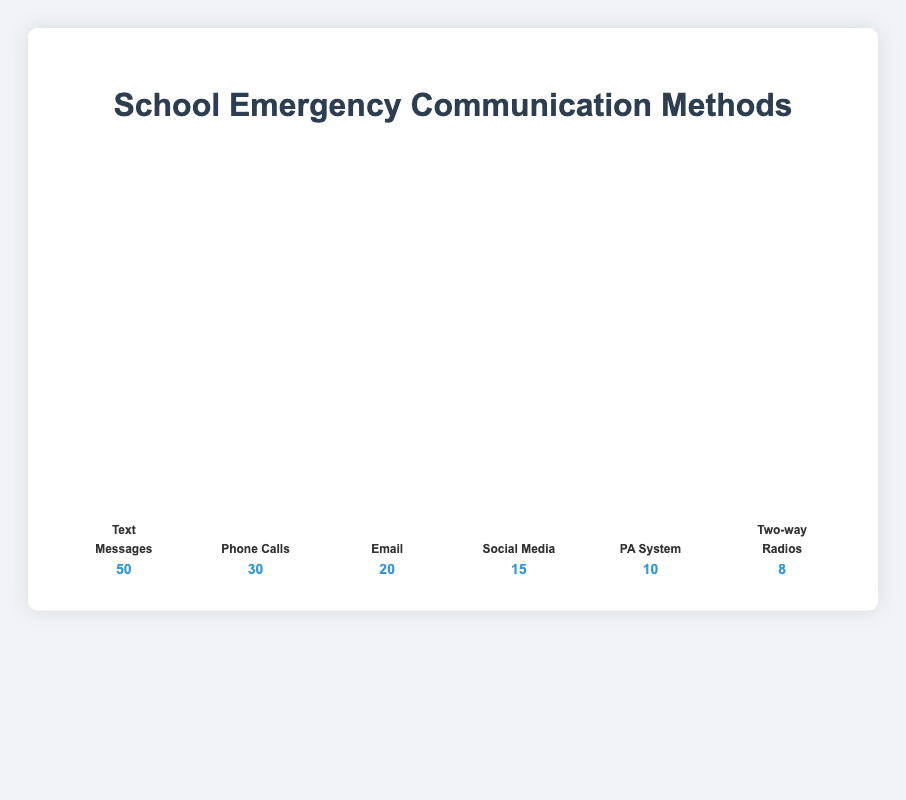Which communication method is used the most during school emergencies? The visual plot shows the number of times different communication methods are used, where each method is represented by icons. By counting the icons, Text Messages have the most at 50.
Answer: Text Messages How many more Text Messages are used compared to Phone Calls? Text Messages are represented by 50 icons, while Phone Calls are represented by 30 icons. The difference is calculated as 50 - 30.
Answer: 20 Which method is used the least during school emergencies? The visual plot shows that Two-way Radios have the fewest icons, representing their use only 8 times.
Answer: Two-way Radios What is the combined total of Email and PA System communications? Emails are represented by 20 icons, and PA System communications are represented by 10 icons. The total is 20 + 10.
Answer: 30 Rank the methods from most used to least used based on the figure. Based on the number of icons, the ranking from most to least used is: Text Messages (50), Phone Calls (30), Email (20), Social Media (15), PA System (10), Two-way Radios (8).
Answer: Text Messages > Phone Calls > Email > Social Media > PA System > Two-way Radios Is the total number of communications through Text Messages, Phone Calls, and Email greater than 90? Text Messages are used 50 times, Phone Calls 30 times, and Emails 20 times. Adding these, the total is 50 + 30 + 20 = 100, which is greater than 90.
Answer: Yes What percentage of the total communication methods does Social Media represent? First, sum the total communications: 50 (Text Messages) + 30 (Phone Calls) + 20 (Emails) + 15 (Social Media) + 10 (PA System) + 8 (Two-way Radios) = 133. The percentage for Social Media is (15/133) * 100.
Answer: Approximately 11.28% Are the combined counts of Social Media and PA System less than the count of Phone Calls? Social Media are represented by 15 icons, and PA System by 10 icons. The sum is 15 + 10 = 25, which is less than the 30 icons representing Phone Calls.
Answer: Yes How many icons are there in total for all communication methods? Adding all the counts: 50 (Text Messages) + 30 (Phone Calls) + 20 (Email) + 15 (Social Media) + 10 (PA System) + 8 (Two-way Radios) = 133.
Answer: 133 